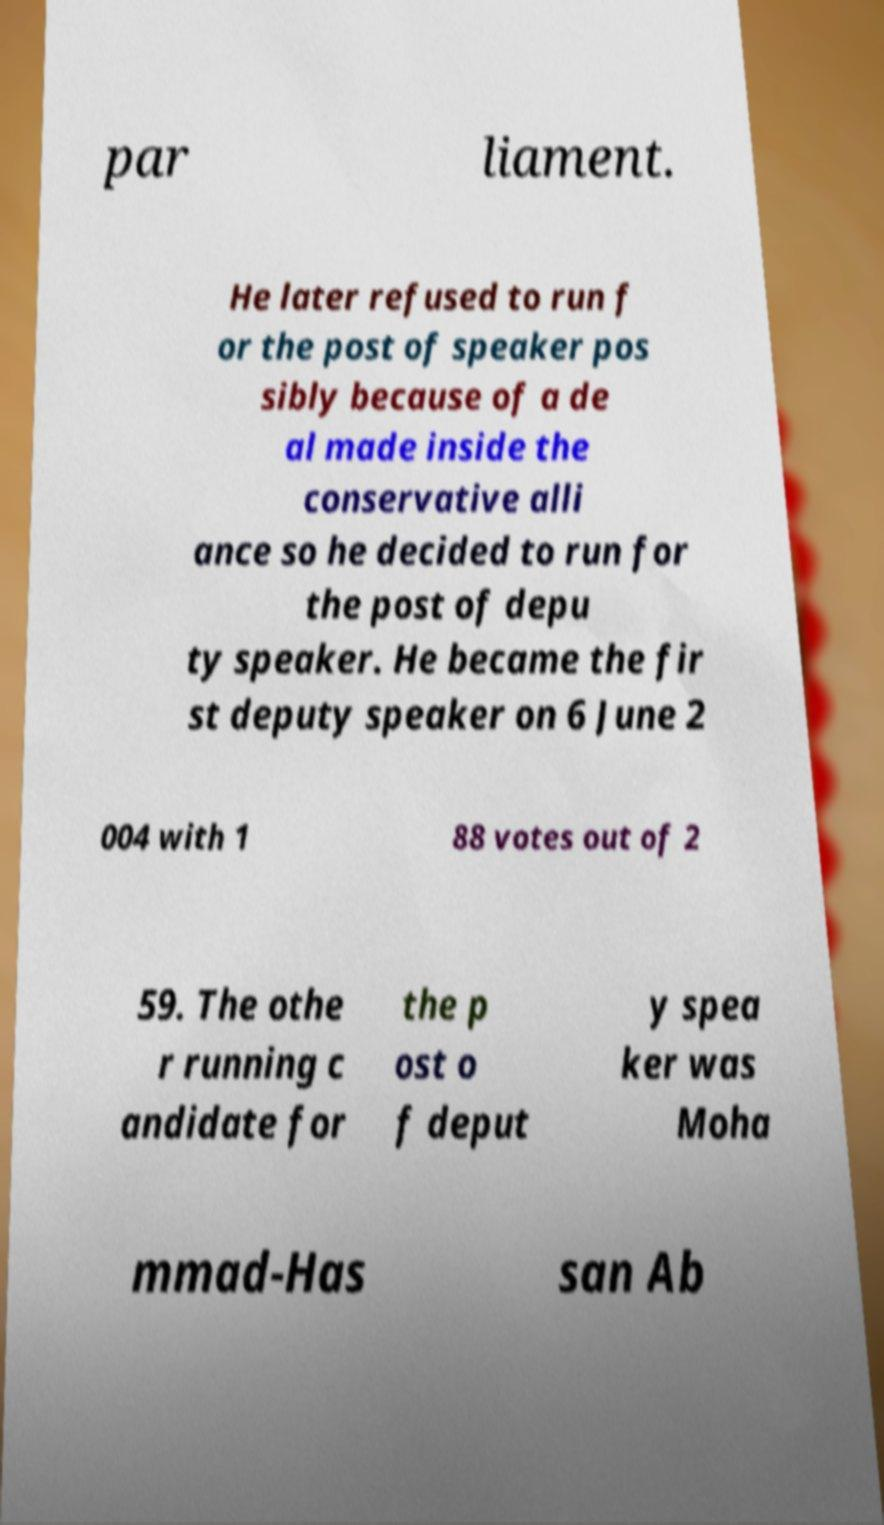Can you read and provide the text displayed in the image?This photo seems to have some interesting text. Can you extract and type it out for me? par liament. He later refused to run f or the post of speaker pos sibly because of a de al made inside the conservative alli ance so he decided to run for the post of depu ty speaker. He became the fir st deputy speaker on 6 June 2 004 with 1 88 votes out of 2 59. The othe r running c andidate for the p ost o f deput y spea ker was Moha mmad-Has san Ab 